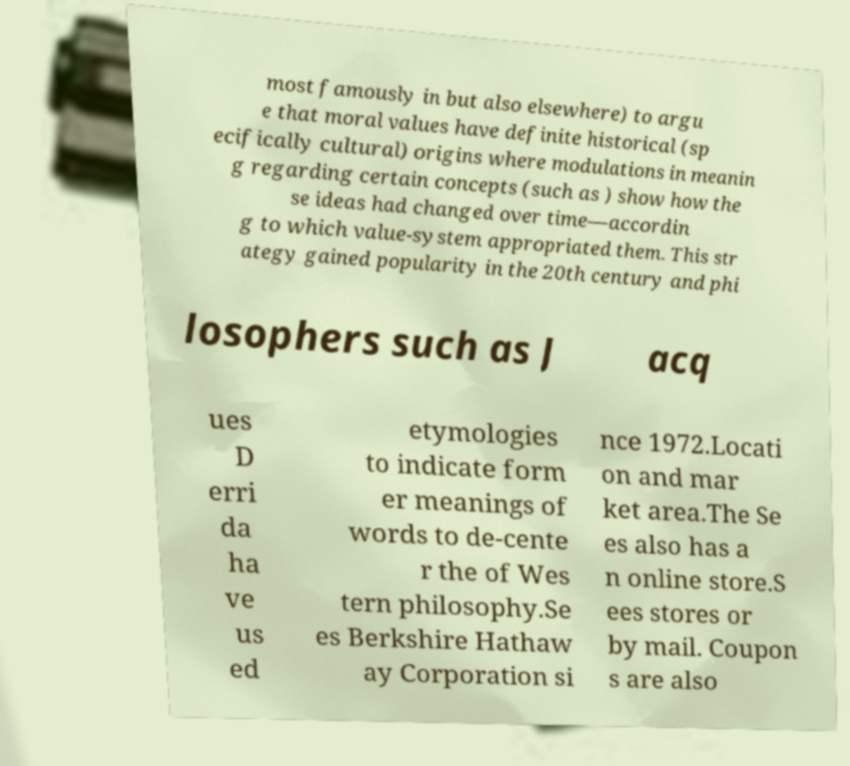I need the written content from this picture converted into text. Can you do that? most famously in but also elsewhere) to argu e that moral values have definite historical (sp ecifically cultural) origins where modulations in meanin g regarding certain concepts (such as ) show how the se ideas had changed over time—accordin g to which value-system appropriated them. This str ategy gained popularity in the 20th century and phi losophers such as J acq ues D erri da ha ve us ed etymologies to indicate form er meanings of words to de-cente r the of Wes tern philosophy.Se es Berkshire Hathaw ay Corporation si nce 1972.Locati on and mar ket area.The Se es also has a n online store.S ees stores or by mail. Coupon s are also 